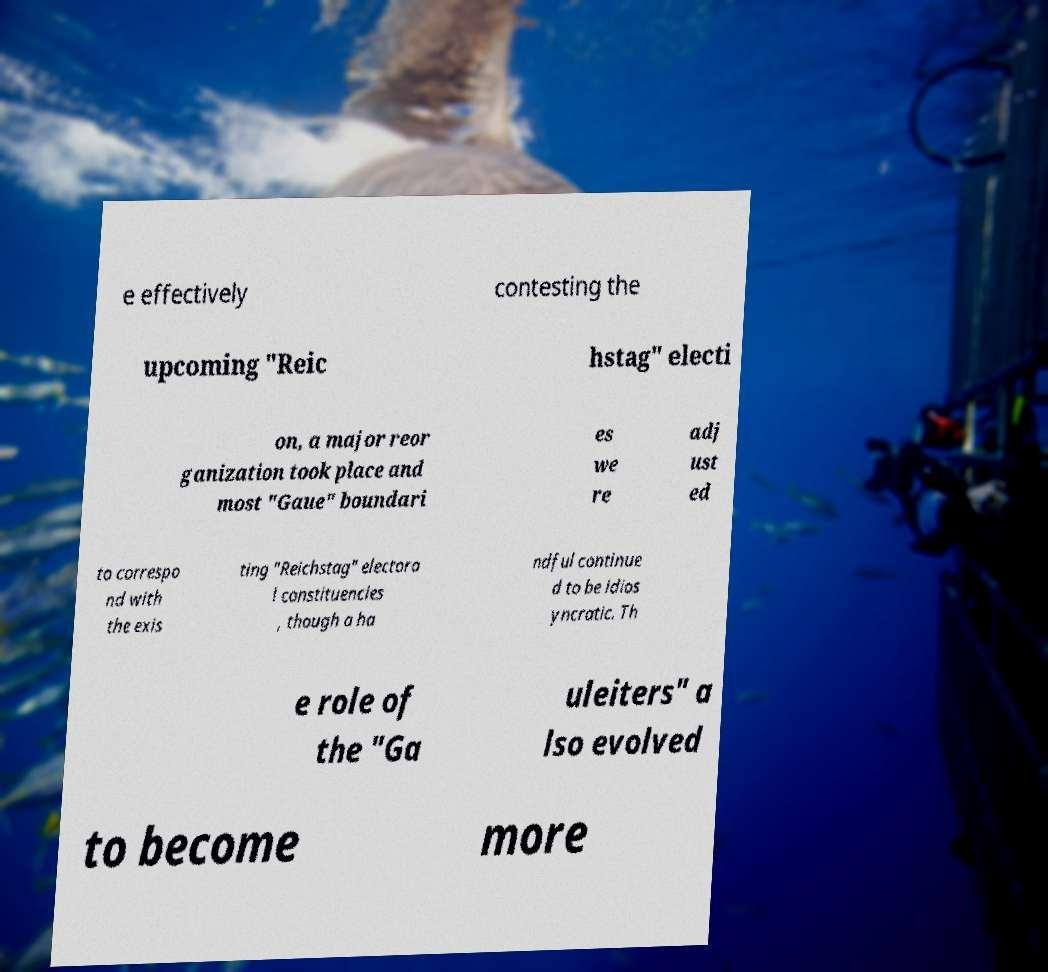There's text embedded in this image that I need extracted. Can you transcribe it verbatim? e effectively contesting the upcoming "Reic hstag" electi on, a major reor ganization took place and most "Gaue" boundari es we re adj ust ed to correspo nd with the exis ting "Reichstag" electora l constituencies , though a ha ndful continue d to be idios yncratic. Th e role of the "Ga uleiters" a lso evolved to become more 